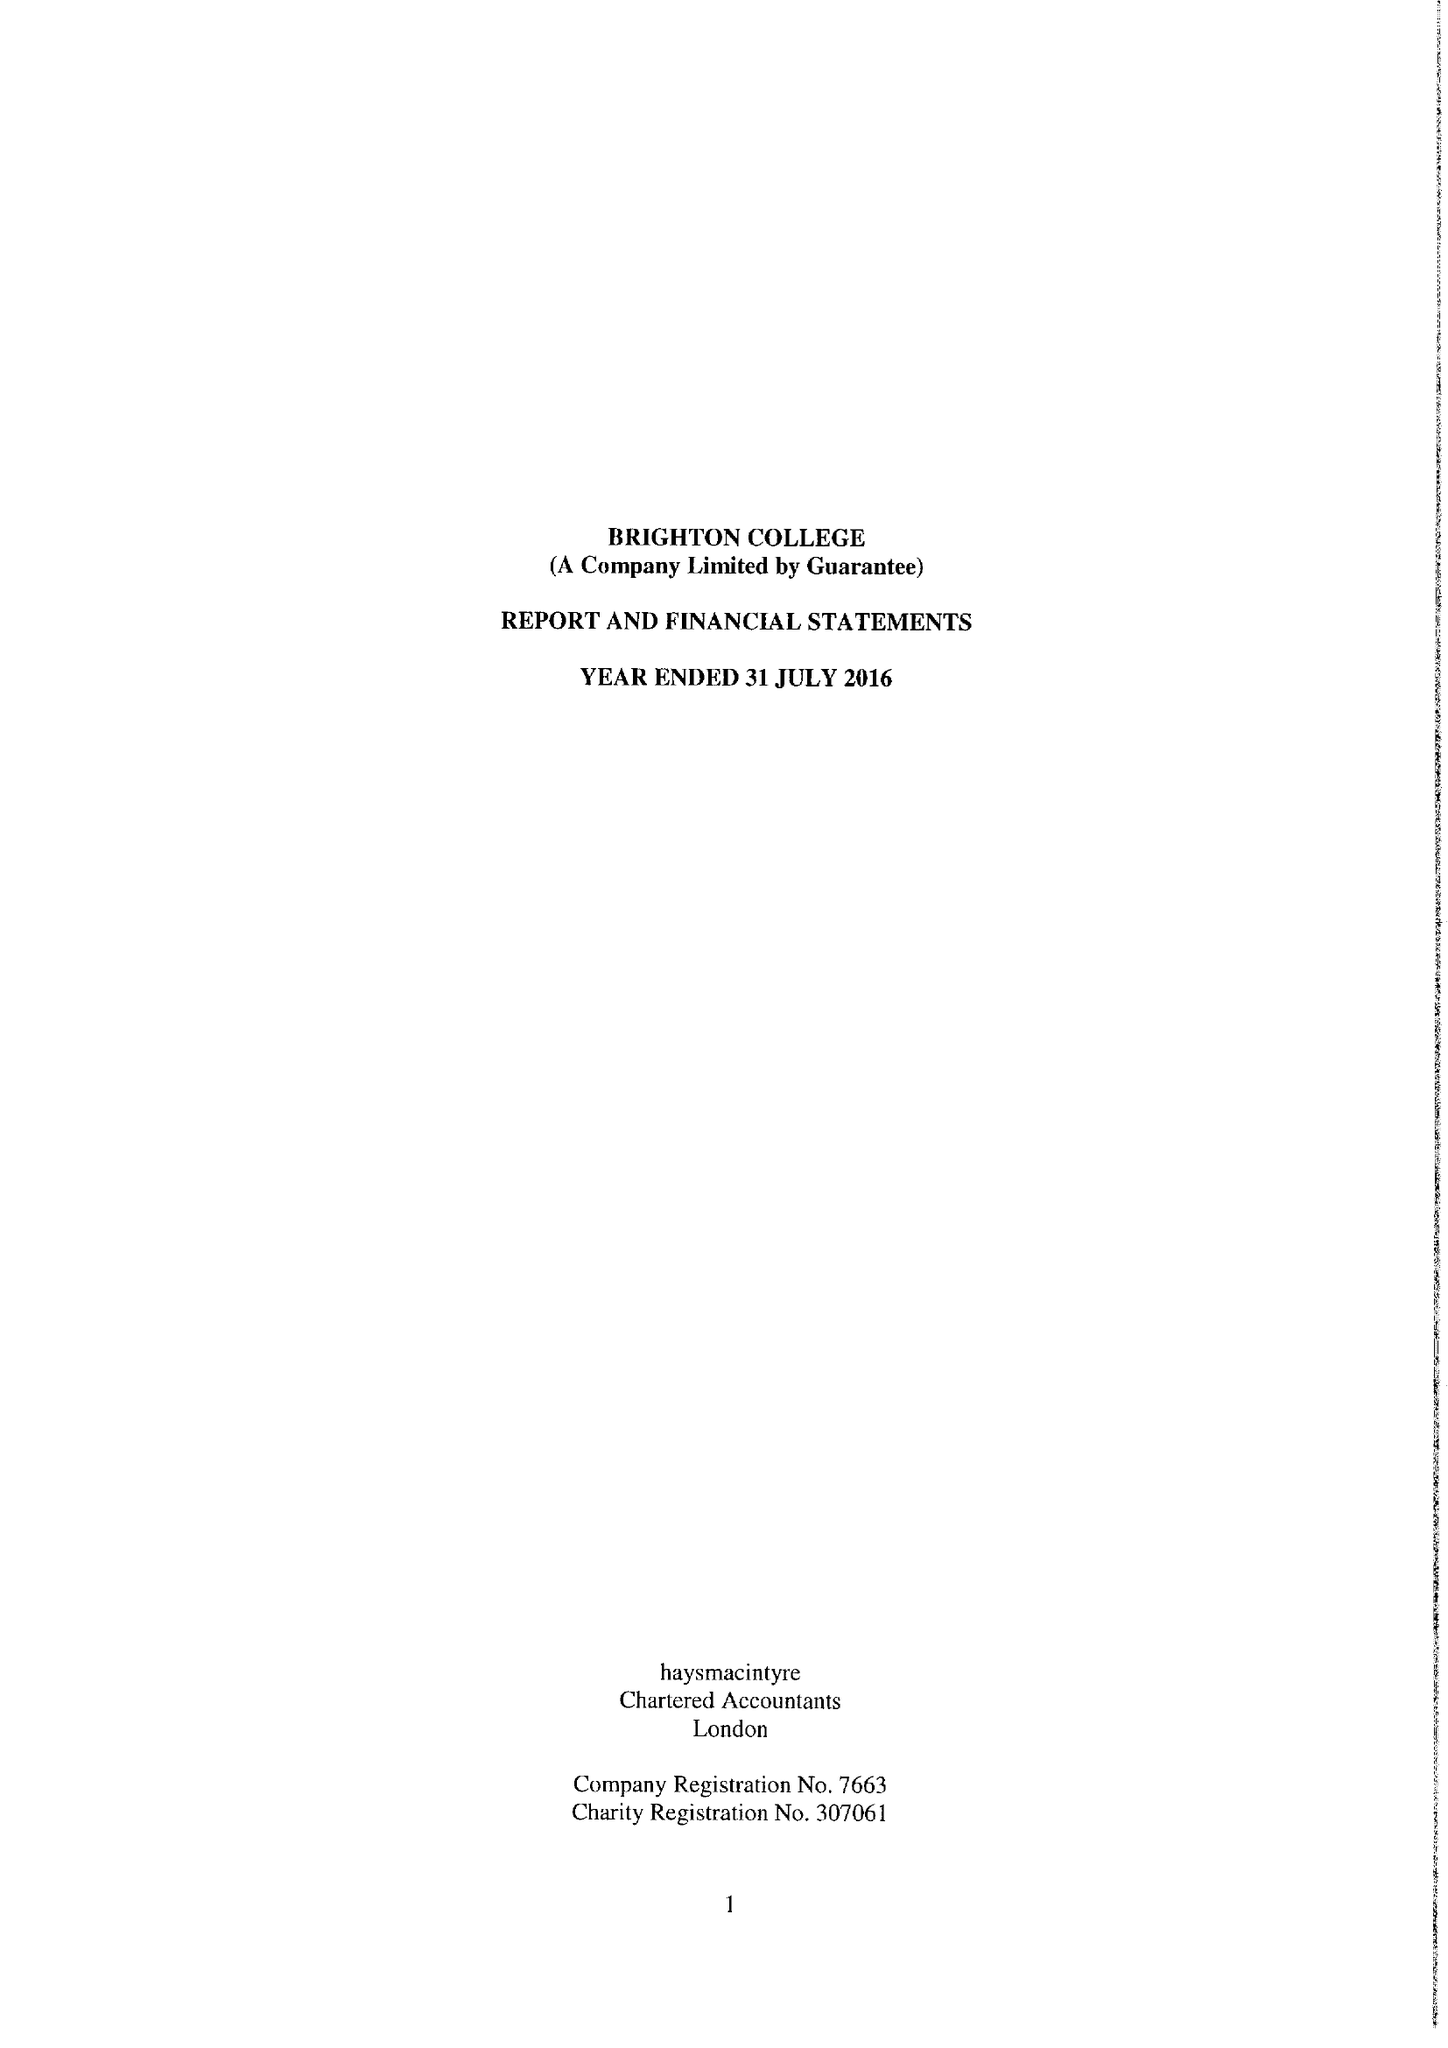What is the value for the address__post_town?
Answer the question using a single word or phrase. BRIGHTON 